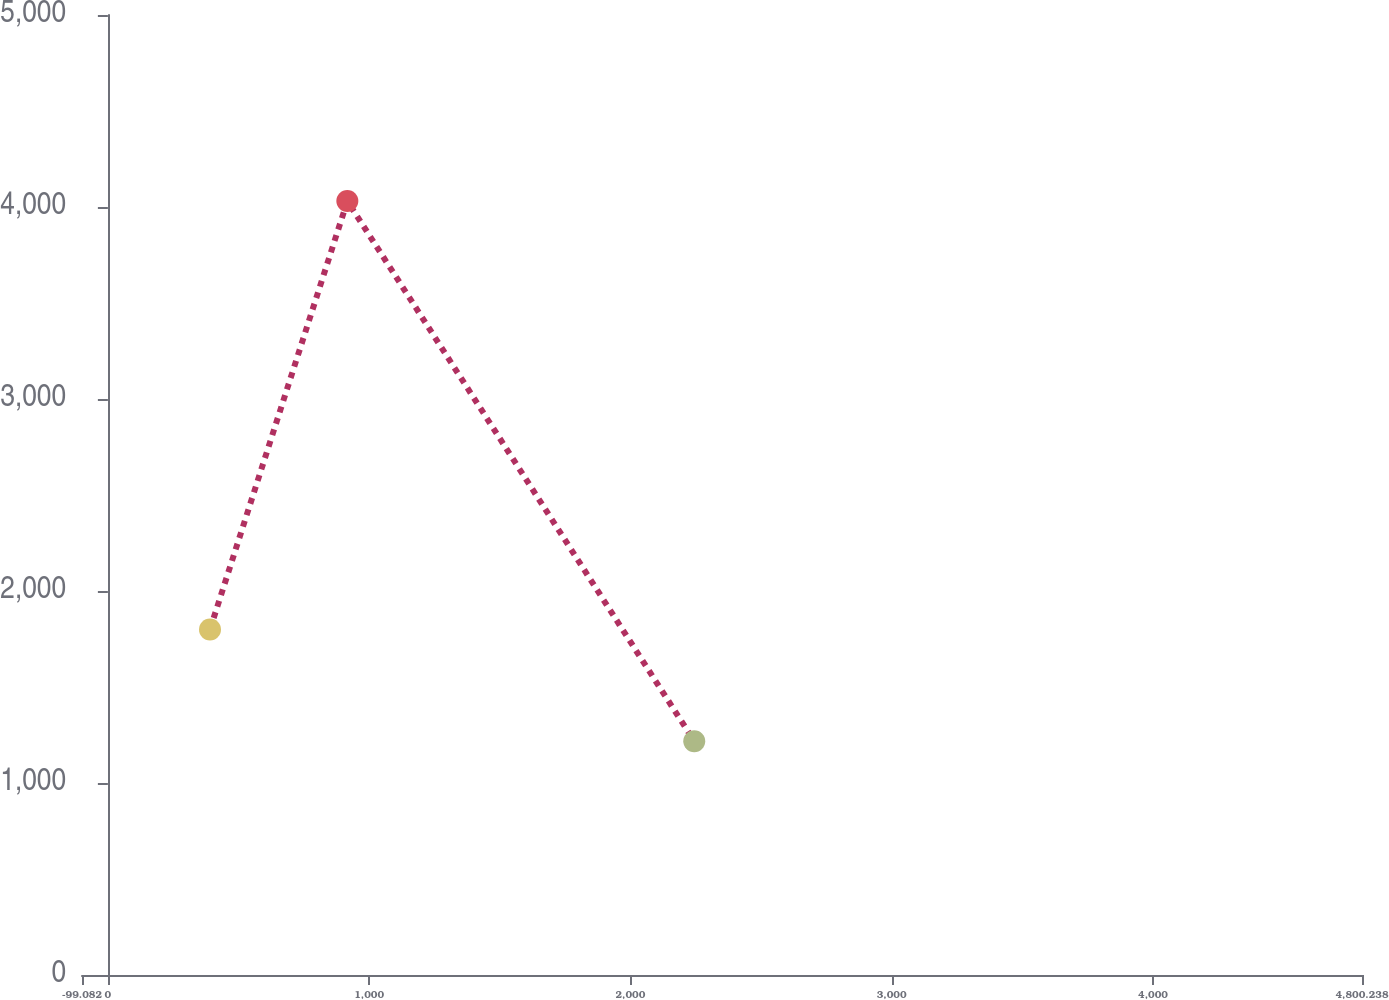Convert chart. <chart><loc_0><loc_0><loc_500><loc_500><line_chart><ecel><fcel>Years Ended December 31,<nl><fcel>390.85<fcel>1799.87<nl><fcel>916.52<fcel>4030.91<nl><fcel>2244.36<fcel>1217.79<nl><fcel>5290.17<fcel>4.56<nl></chart> 